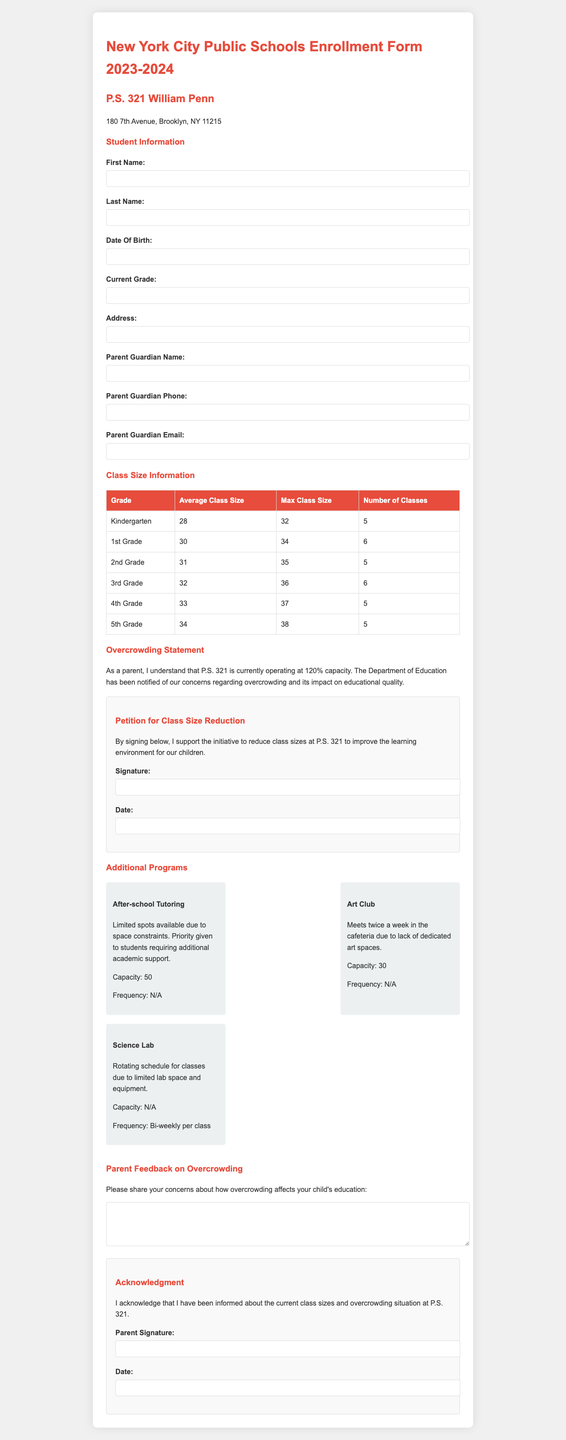What is the average class size for 4th Grade? The average class size for 4th Grade is found in the class size information section of the document.
Answer: 33 What is the maximum class size for Kindergarten? The maximum class size for Kindergarten can be found in the class size information table.
Answer: 32 How many classes are there for 1st Grade? The number of classes for 1st Grade is listed in the class size information section.
Answer: 6 What is the capacity for the After-school Tutoring program? The capacity for the After-school Tutoring program is mentioned in the additional programs section.
Answer: 50 What is the date of the class size reduction petition? The date section in the class size reduction petition section of the form is left blank for the parent to fill out.
Answer: (to be filled in) What is the current capacity utilization of P.S. 321? The overcrowding statement details the current capacity utilization of the school.
Answer: 120% What is the description of the Science Lab program? The description is provided in the additional programs section.
Answer: Rotating schedule for classes due to limited lab space and equipment What do parents need to acknowledge in the acknowledgment section? The acknowledgment statement informs parents about current class sizes and overcrowding.
Answer: Current class sizes and overcrowding situation at P.S. 321 